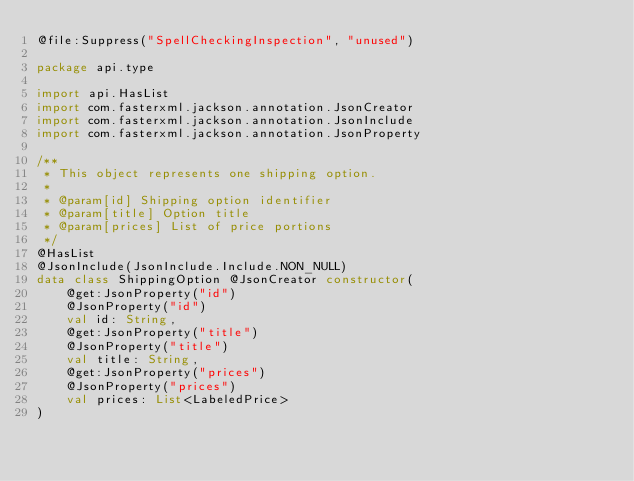Convert code to text. <code><loc_0><loc_0><loc_500><loc_500><_Kotlin_>@file:Suppress("SpellCheckingInspection", "unused")

package api.type

import api.HasList
import com.fasterxml.jackson.annotation.JsonCreator
import com.fasterxml.jackson.annotation.JsonInclude
import com.fasterxml.jackson.annotation.JsonProperty

/**
 * This object represents one shipping option.
 *
 * @param[id] Shipping option identifier
 * @param[title] Option title
 * @param[prices] List of price portions
 */
@HasList
@JsonInclude(JsonInclude.Include.NON_NULL)
data class ShippingOption @JsonCreator constructor(
    @get:JsonProperty("id")
    @JsonProperty("id")
    val id: String,
    @get:JsonProperty("title")
    @JsonProperty("title")
    val title: String,
    @get:JsonProperty("prices")
    @JsonProperty("prices")
    val prices: List<LabeledPrice>
)</code> 